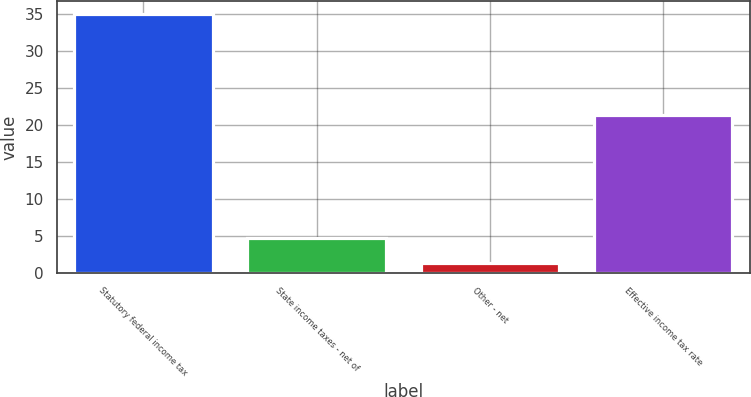Convert chart to OTSL. <chart><loc_0><loc_0><loc_500><loc_500><bar_chart><fcel>Statutory federal income tax<fcel>State income taxes - net of<fcel>Other - net<fcel>Effective income tax rate<nl><fcel>35<fcel>4.67<fcel>1.3<fcel>21.4<nl></chart> 